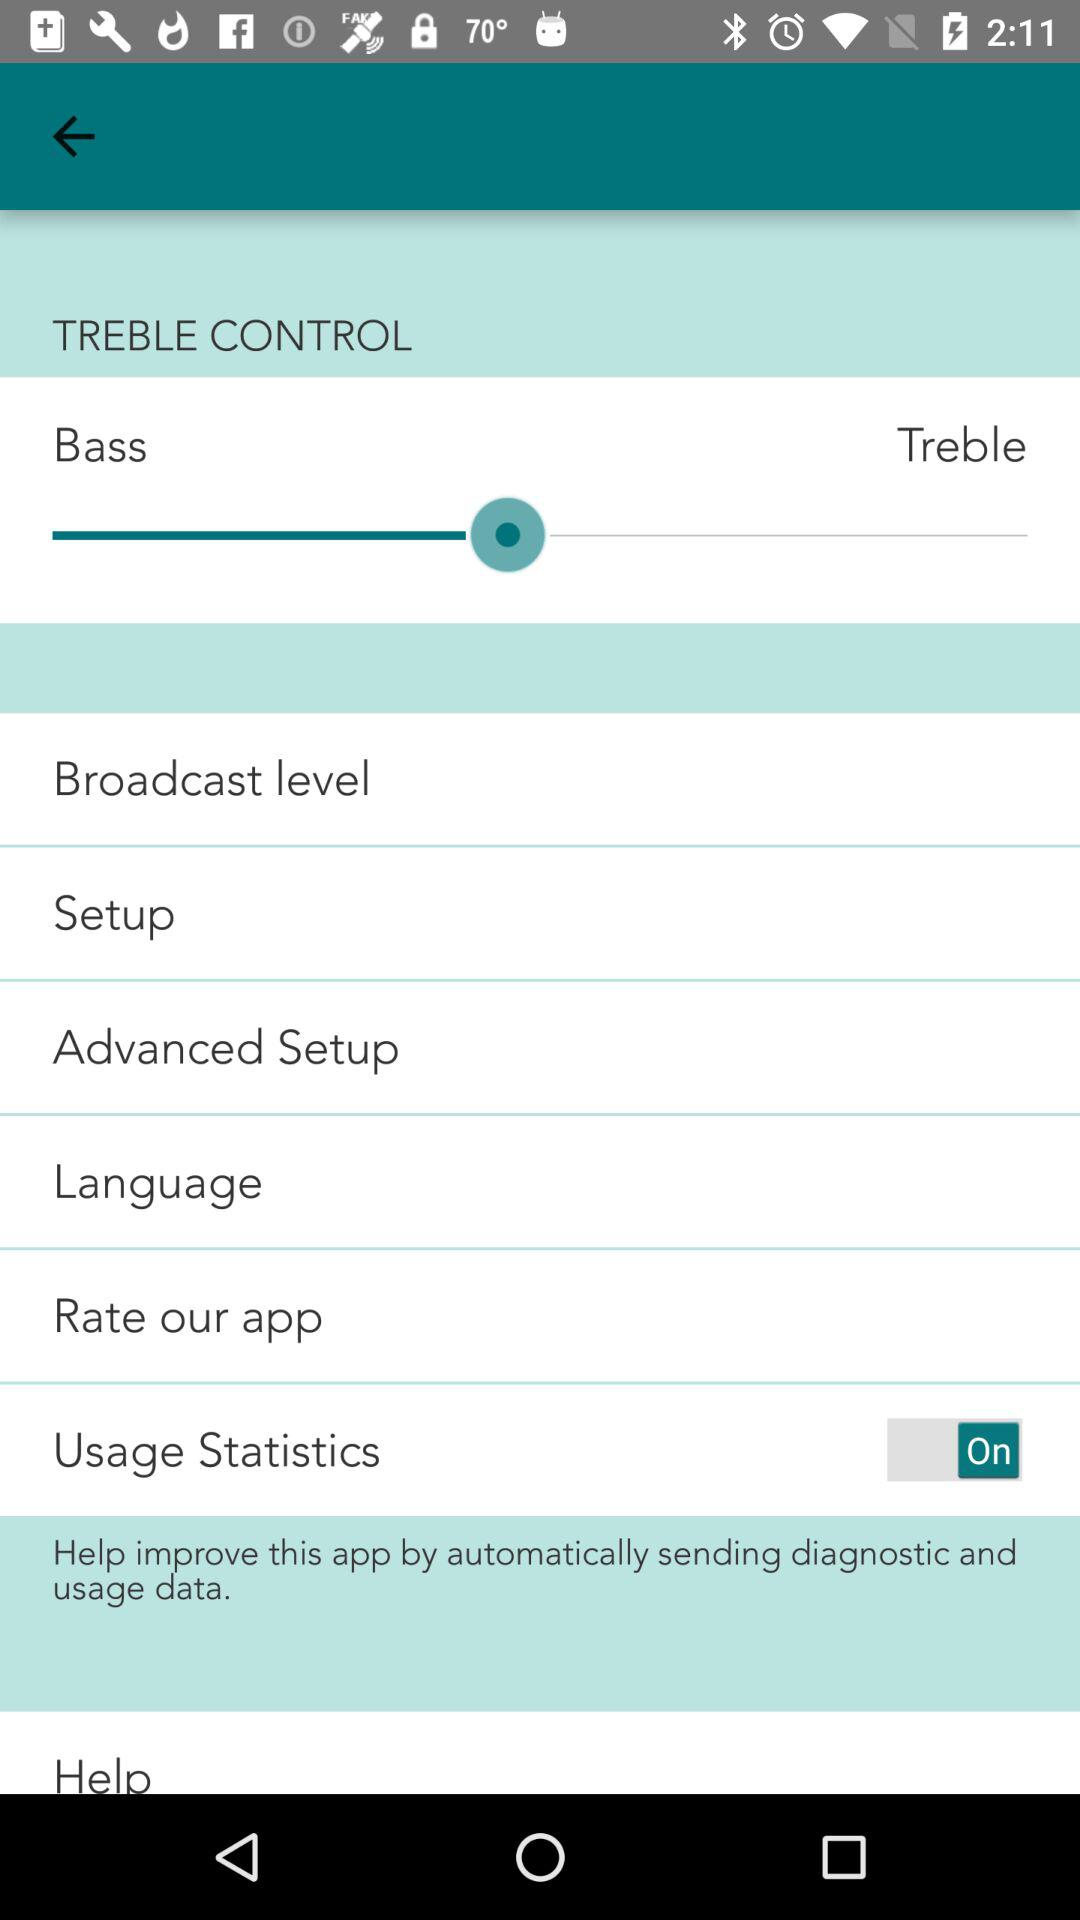What is the status of "Usage Statistics"? The status is "on". 